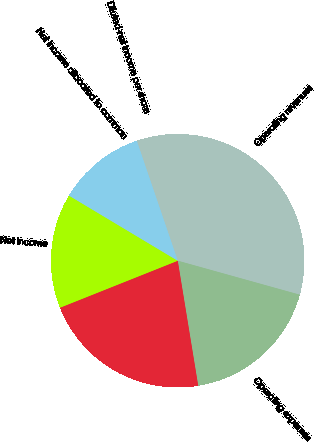Convert chart to OTSL. <chart><loc_0><loc_0><loc_500><loc_500><pie_chart><fcel>Operating revenues<fcel>Operating expenses<fcel>Operating income<fcel>Net income<fcel>Net income allocated to common<fcel>Diluted-net income per share<nl><fcel>34.56%<fcel>18.09%<fcel>21.54%<fcel>14.63%<fcel>11.17%<fcel>0.0%<nl></chart> 